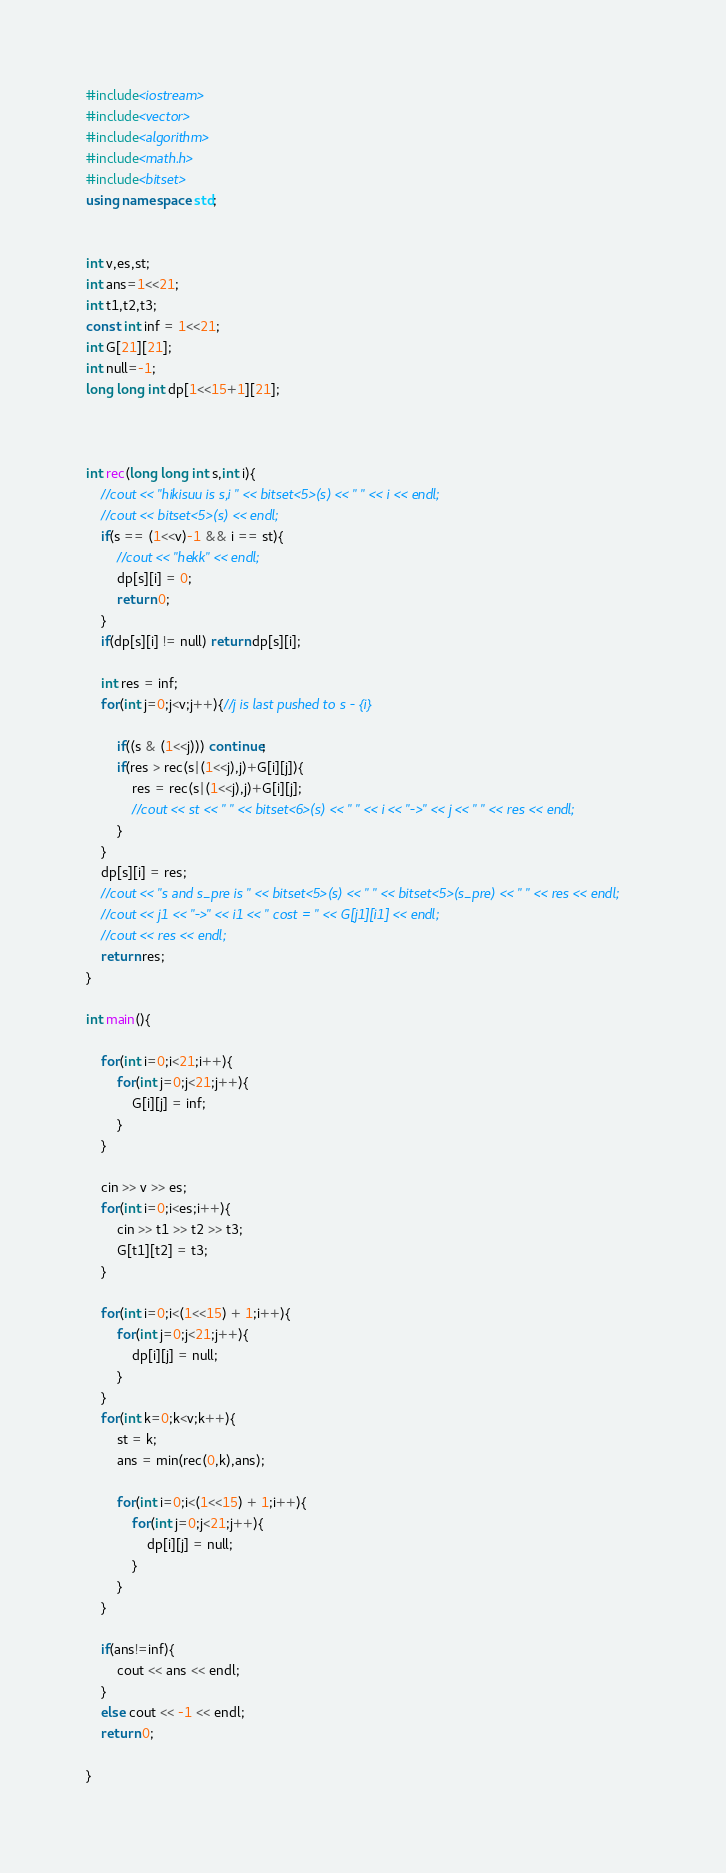<code> <loc_0><loc_0><loc_500><loc_500><_C++_>#include<iostream>
#include<vector>
#include<algorithm>
#include<math.h>
#include<bitset>
using namespace std;


int v,es,st;
int ans=1<<21;
int t1,t2,t3;
const int inf = 1<<21;
int G[21][21];
int null=-1;
long long int dp[1<<15+1][21];



int rec(long long int s,int i){
    //cout << "hikisuu is s,i " << bitset<5>(s) << " " << i << endl;
    //cout << bitset<5>(s) << endl;
    if(s == (1<<v)-1 && i == st){
        //cout << "hekk" << endl;
        dp[s][i] = 0;
        return 0;
    }
    if(dp[s][i] != null) return dp[s][i];

    int res = inf;
    for(int j=0;j<v;j++){//j is last pushed to s - {i}
        
        if((s & (1<<j))) continue;
        if(res > rec(s|(1<<j),j)+G[i][j]){
            res = rec(s|(1<<j),j)+G[i][j];
            //cout << st << " " << bitset<6>(s) << " " << i << "->" << j << " " << res << endl; 
        }
    }
    dp[s][i] = res;
    //cout << "s and s_pre is " << bitset<5>(s) << " " << bitset<5>(s_pre) << " " << res << endl;
    //cout << j1 << "->" << i1 << " cost = " << G[j1][i1] << endl;
    //cout << res << endl;
    return res;
}

int main(){

    for(int i=0;i<21;i++){
        for(int j=0;j<21;j++){
            G[i][j] = inf;
        }
    }

    cin >> v >> es;
    for(int i=0;i<es;i++){
        cin >> t1 >> t2 >> t3;
        G[t1][t2] = t3;
    }

    for(int i=0;i<(1<<15) + 1;i++){
        for(int j=0;j<21;j++){
            dp[i][j] = null;
        }
    }
    for(int k=0;k<v;k++){
        st = k;
        ans = min(rec(0,k),ans);

        for(int i=0;i<(1<<15) + 1;i++){
            for(int j=0;j<21;j++){
                dp[i][j] = null;
            }
        }
    }

    if(ans!=inf){
        cout << ans << endl;
    }
    else cout << -1 << endl;
    return 0;

}
</code> 